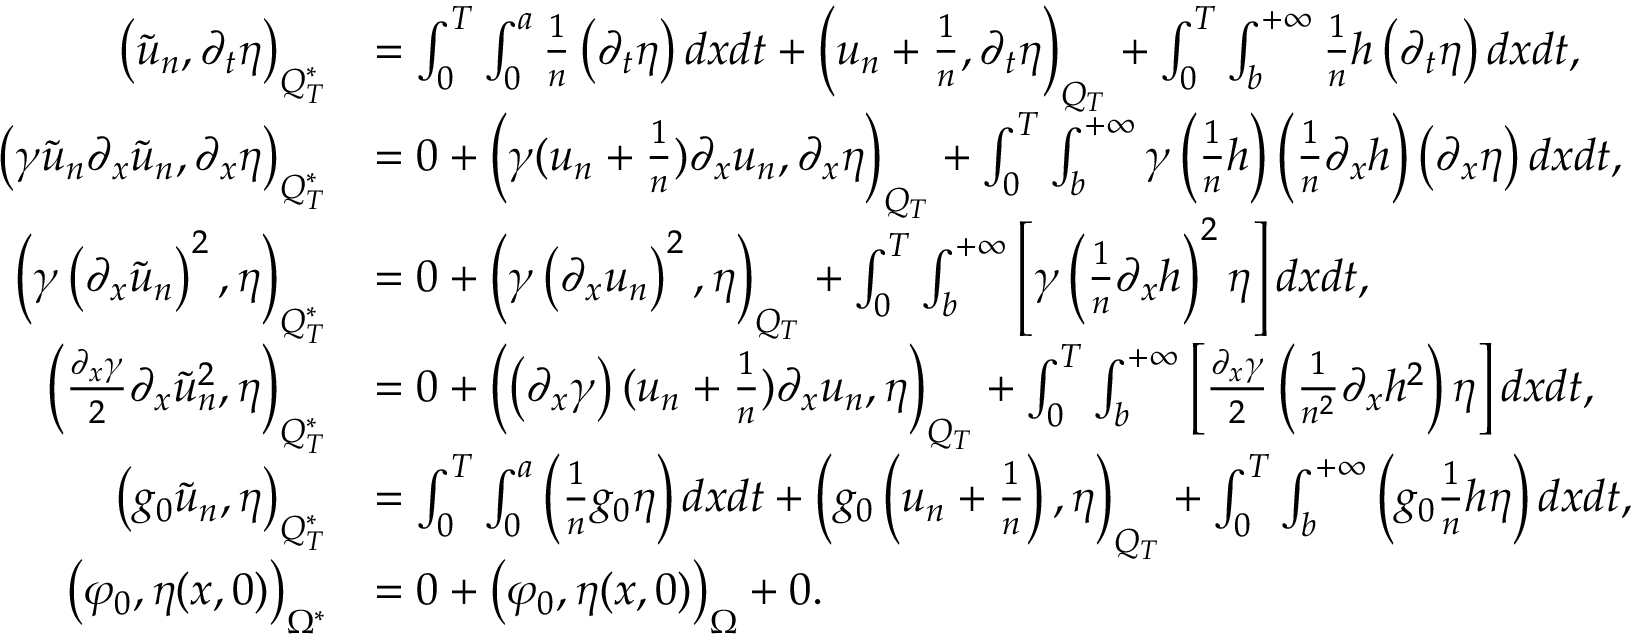Convert formula to latex. <formula><loc_0><loc_0><loc_500><loc_500>\begin{array} { r l } { \left ( \tilde { u } _ { n } , \partial _ { t } \eta \right ) _ { Q _ { T } ^ { * } } } & { = \int _ { 0 } ^ { T } \int _ { 0 } ^ { a } \frac { 1 } { n } \left ( \partial _ { t } \eta \right ) d x d t + \left ( u _ { n } + \frac { 1 } { n } , \partial _ { t } \eta \right ) _ { Q _ { T } } + \int _ { 0 } ^ { T } \int _ { b } ^ { + \infty } \frac { 1 } { n } h \left ( \partial _ { t } \eta \right ) d x d t , } \\ { \left ( \gamma \tilde { u } _ { n } \partial _ { x } \tilde { u } _ { n } , \partial _ { x } \eta \right ) _ { Q _ { T } ^ { * } } } & { = 0 + \left ( \gamma ( u _ { n } + \frac { 1 } { n } ) \partial _ { x } u _ { n } , \partial _ { x } \eta \right ) _ { Q _ { T } } + \int _ { 0 } ^ { T } \int _ { b } ^ { + \infty } \gamma \left ( \frac { 1 } { n } h \right ) \left ( \frac { 1 } { n } \partial _ { x } h \right ) \left ( \partial _ { x } \eta \right ) d x d t , } \\ { \left ( \gamma \left ( \partial _ { x } \tilde { u } _ { n } \right ) ^ { 2 } , \eta \right ) _ { Q _ { T } ^ { * } } } & { = 0 + \left ( \gamma \left ( \partial _ { x } u _ { n } \right ) ^ { 2 } , \eta \right ) _ { Q _ { T } } + \int _ { 0 } ^ { T } \int _ { b } ^ { + \infty } \left [ \gamma \left ( \frac { 1 } { n } \partial _ { x } h \right ) ^ { 2 } \eta \right ] d x d t , } \\ { \left ( \frac { \partial _ { x } \gamma } { 2 } \partial _ { x } \tilde { u } _ { n } ^ { 2 } , \eta \right ) _ { Q _ { T } ^ { * } } } & { = 0 + \left ( \left ( \partial _ { x } \gamma \right ) ( u _ { n } + \frac { 1 } { n } ) \partial _ { x } u _ { n } , \eta \right ) _ { Q _ { T } } + \int _ { 0 } ^ { T } \int _ { b } ^ { + \infty } \left [ \frac { \partial _ { x } \gamma } { 2 } \left ( \frac { 1 } { n ^ { 2 } } \partial _ { x } h ^ { 2 } \right ) \eta \right ] d x d t , } \\ { \left ( g _ { 0 } \tilde { u } _ { n } , \eta \right ) _ { Q _ { T } ^ { * } } } & { = \int _ { 0 } ^ { T } \int _ { 0 } ^ { a } \left ( \frac { 1 } { n } g _ { 0 } \eta \right ) d x d t + \left ( g _ { 0 } \left ( u _ { n } + \frac { 1 } { n } \right ) , \eta \right ) _ { Q _ { T } } + \int _ { 0 } ^ { T } \int _ { b } ^ { + \infty } \left ( g _ { 0 } \frac { 1 } { n } h \eta \right ) d x d t , } \\ { \left ( \varphi _ { 0 } , \eta ( x , 0 ) \right ) _ { \Omega ^ { * } } } & { = 0 + \left ( \varphi _ { 0 } , \eta ( x , 0 ) \right ) _ { \Omega } + 0 . } \end{array}</formula> 